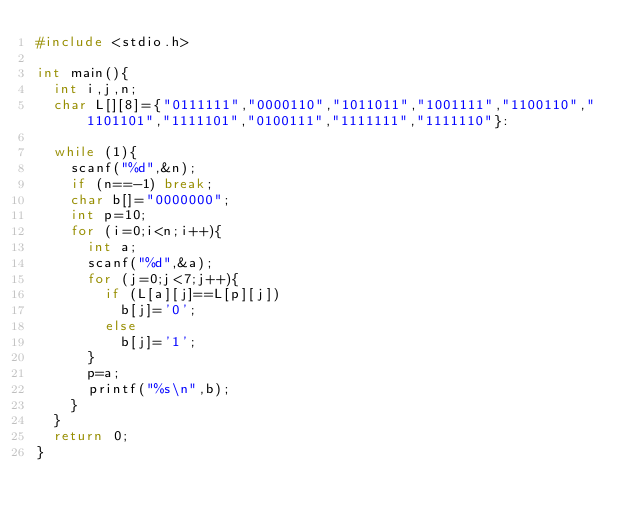Convert code to text. <code><loc_0><loc_0><loc_500><loc_500><_C_>#include <stdio.h>

int main(){
  int i,j,n;
  char L[][8]={"0111111","0000110","1011011","1001111","1100110","1101101","1111101","0100111","1111111","1111110"}:

  while (1){
    scanf("%d",&n);
    if (n==-1) break;
    char b[]="0000000";
    int p=10;
    for (i=0;i<n;i++){
      int a;
      scanf("%d",&a);
      for (j=0;j<7;j++){
        if (L[a][j]==L[p][j])
          b[j]='0';
        else
          b[j]='1';
      }
      p=a;
      printf("%s\n",b);
    }
  }
  return 0;
}</code> 